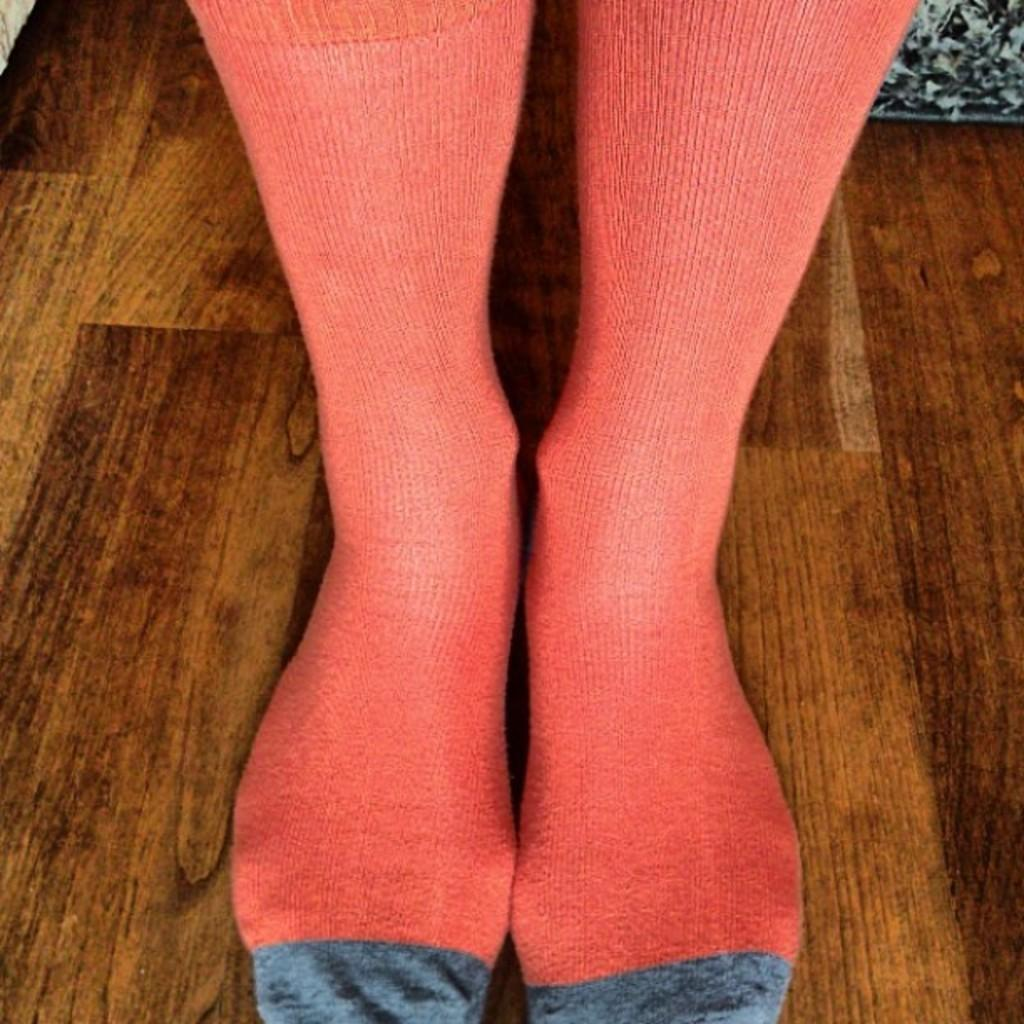What body part can be seen in the image? There are legs visible in the image. What are the legs wearing? The legs are wearing socks. What is the surface beneath the legs? There is a floor at the bottom of the image. What type of cave can be seen in the image? There is no cave present in the image; it only shows legs wearing socks and a floor. 